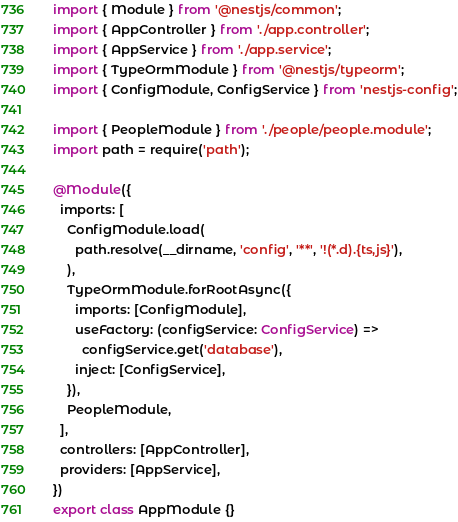Convert code to text. <code><loc_0><loc_0><loc_500><loc_500><_TypeScript_>import { Module } from '@nestjs/common';
import { AppController } from './app.controller';
import { AppService } from './app.service';
import { TypeOrmModule } from '@nestjs/typeorm';
import { ConfigModule, ConfigService } from 'nestjs-config';

import { PeopleModule } from './people/people.module';
import path = require('path');

@Module({
  imports: [
    ConfigModule.load(
      path.resolve(__dirname, 'config', '**', '!(*.d).{ts,js}'),
    ),
    TypeOrmModule.forRootAsync({
      imports: [ConfigModule],
      useFactory: (configService: ConfigService) =>
        configService.get('database'),
      inject: [ConfigService],
    }),
    PeopleModule,
  ],
  controllers: [AppController],
  providers: [AppService],
})
export class AppModule {}
</code> 